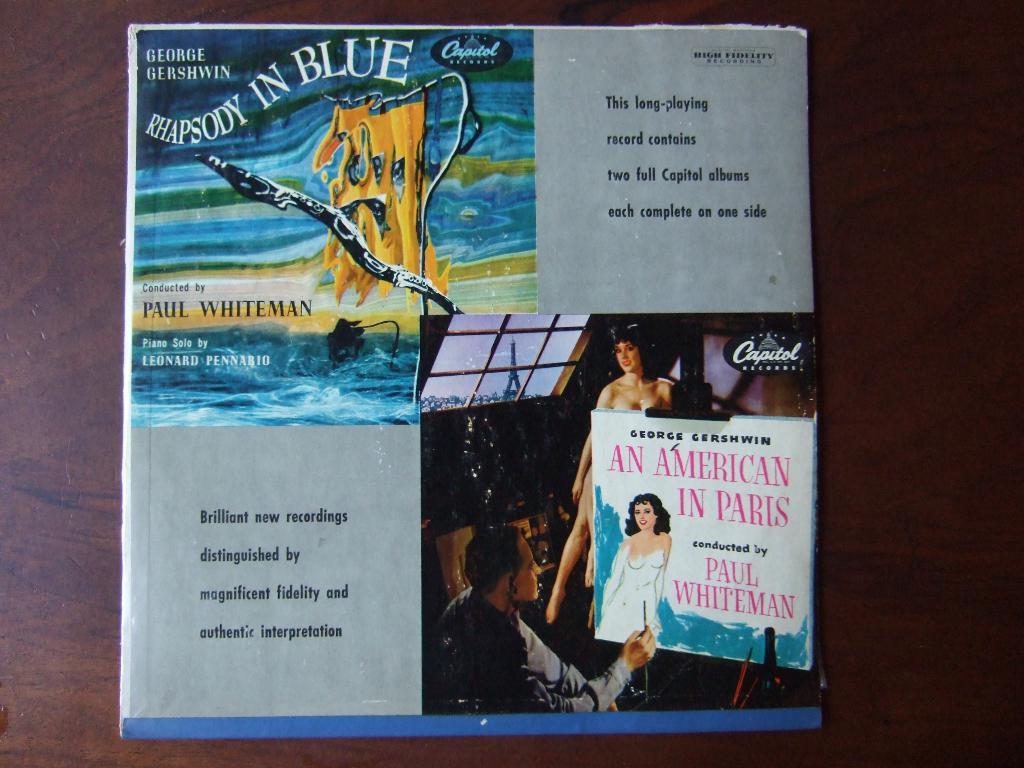What is the name in the top left corner?
Give a very brief answer. George gershwin. What is the name of the album?
Offer a terse response. Rhapsody in blue. 